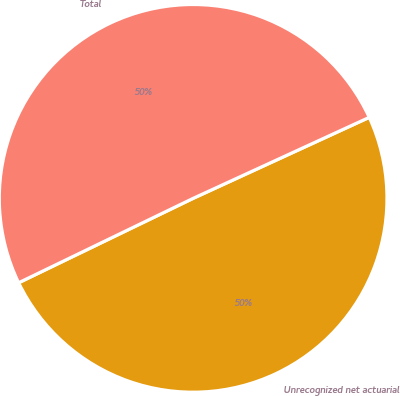<chart> <loc_0><loc_0><loc_500><loc_500><pie_chart><fcel>Unrecognized net actuarial<fcel>Total<nl><fcel>49.69%<fcel>50.31%<nl></chart> 